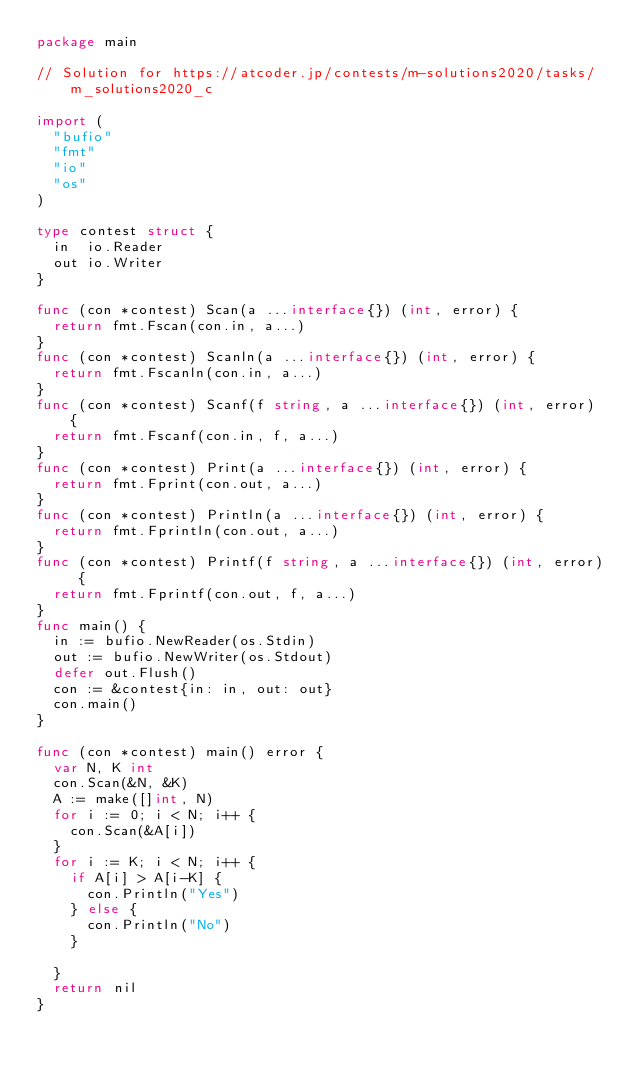Convert code to text. <code><loc_0><loc_0><loc_500><loc_500><_Go_>package main

// Solution for https://atcoder.jp/contests/m-solutions2020/tasks/m_solutions2020_c

import (
	"bufio"
	"fmt"
	"io"
	"os"
)

type contest struct {
	in  io.Reader
	out io.Writer
}

func (con *contest) Scan(a ...interface{}) (int, error) {
	return fmt.Fscan(con.in, a...)
}
func (con *contest) Scanln(a ...interface{}) (int, error) {
	return fmt.Fscanln(con.in, a...)
}
func (con *contest) Scanf(f string, a ...interface{}) (int, error) {
	return fmt.Fscanf(con.in, f, a...)
}
func (con *contest) Print(a ...interface{}) (int, error) {
	return fmt.Fprint(con.out, a...)
}
func (con *contest) Println(a ...interface{}) (int, error) {
	return fmt.Fprintln(con.out, a...)
}
func (con *contest) Printf(f string, a ...interface{}) (int, error) {
	return fmt.Fprintf(con.out, f, a...)
}
func main() {
	in := bufio.NewReader(os.Stdin)
	out := bufio.NewWriter(os.Stdout)
	defer out.Flush()
	con := &contest{in: in, out: out}
	con.main()
}

func (con *contest) main() error {
	var N, K int
	con.Scan(&N, &K)
	A := make([]int, N)
	for i := 0; i < N; i++ {
		con.Scan(&A[i])
	}
	for i := K; i < N; i++ {
		if A[i] > A[i-K] {
			con.Println("Yes")
		} else {
			con.Println("No")
		}

	}
	return nil
}
</code> 